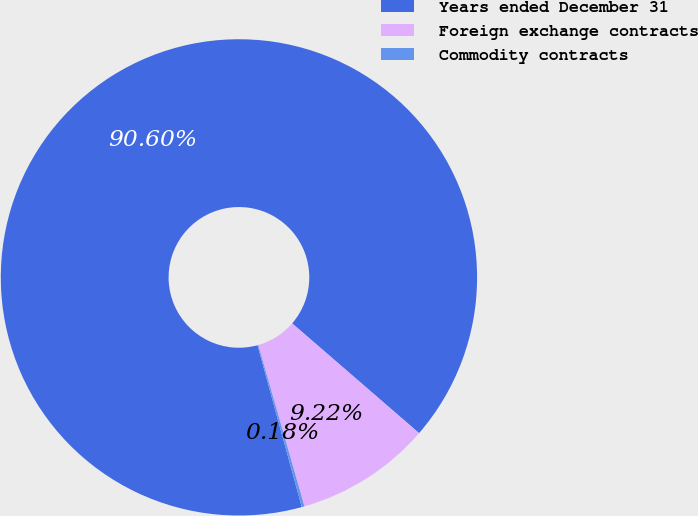Convert chart to OTSL. <chart><loc_0><loc_0><loc_500><loc_500><pie_chart><fcel>Years ended December 31<fcel>Foreign exchange contracts<fcel>Commodity contracts<nl><fcel>90.6%<fcel>9.22%<fcel>0.18%<nl></chart> 